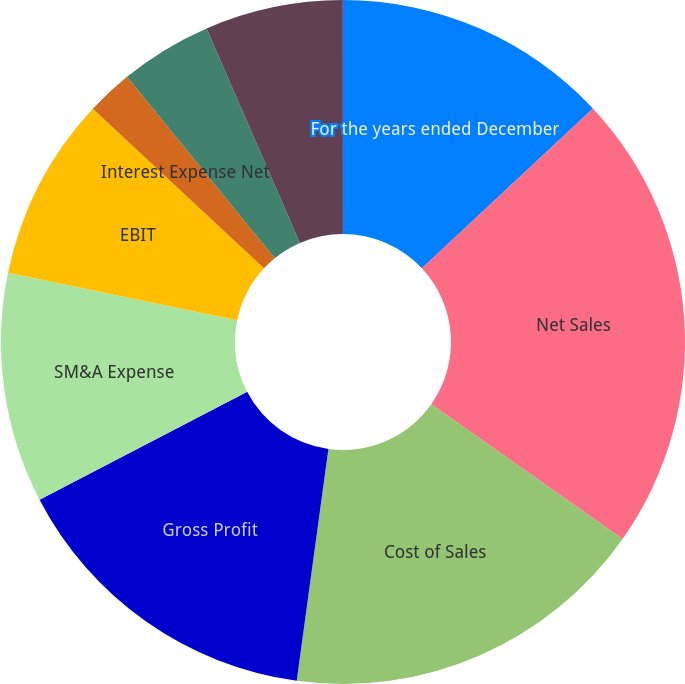Convert chart. <chart><loc_0><loc_0><loc_500><loc_500><pie_chart><fcel>For the years ended December<fcel>Net Sales<fcel>Cost of Sales<fcel>Gross Profit<fcel>SM&A Expense<fcel>EBIT<fcel>Interest Expense Net<fcel>Provision for Income Taxes<fcel>Net Income<fcel>Net Income Per Share-Diluted<nl><fcel>13.04%<fcel>21.73%<fcel>17.39%<fcel>15.21%<fcel>10.87%<fcel>8.7%<fcel>2.18%<fcel>4.35%<fcel>6.52%<fcel>0.01%<nl></chart> 